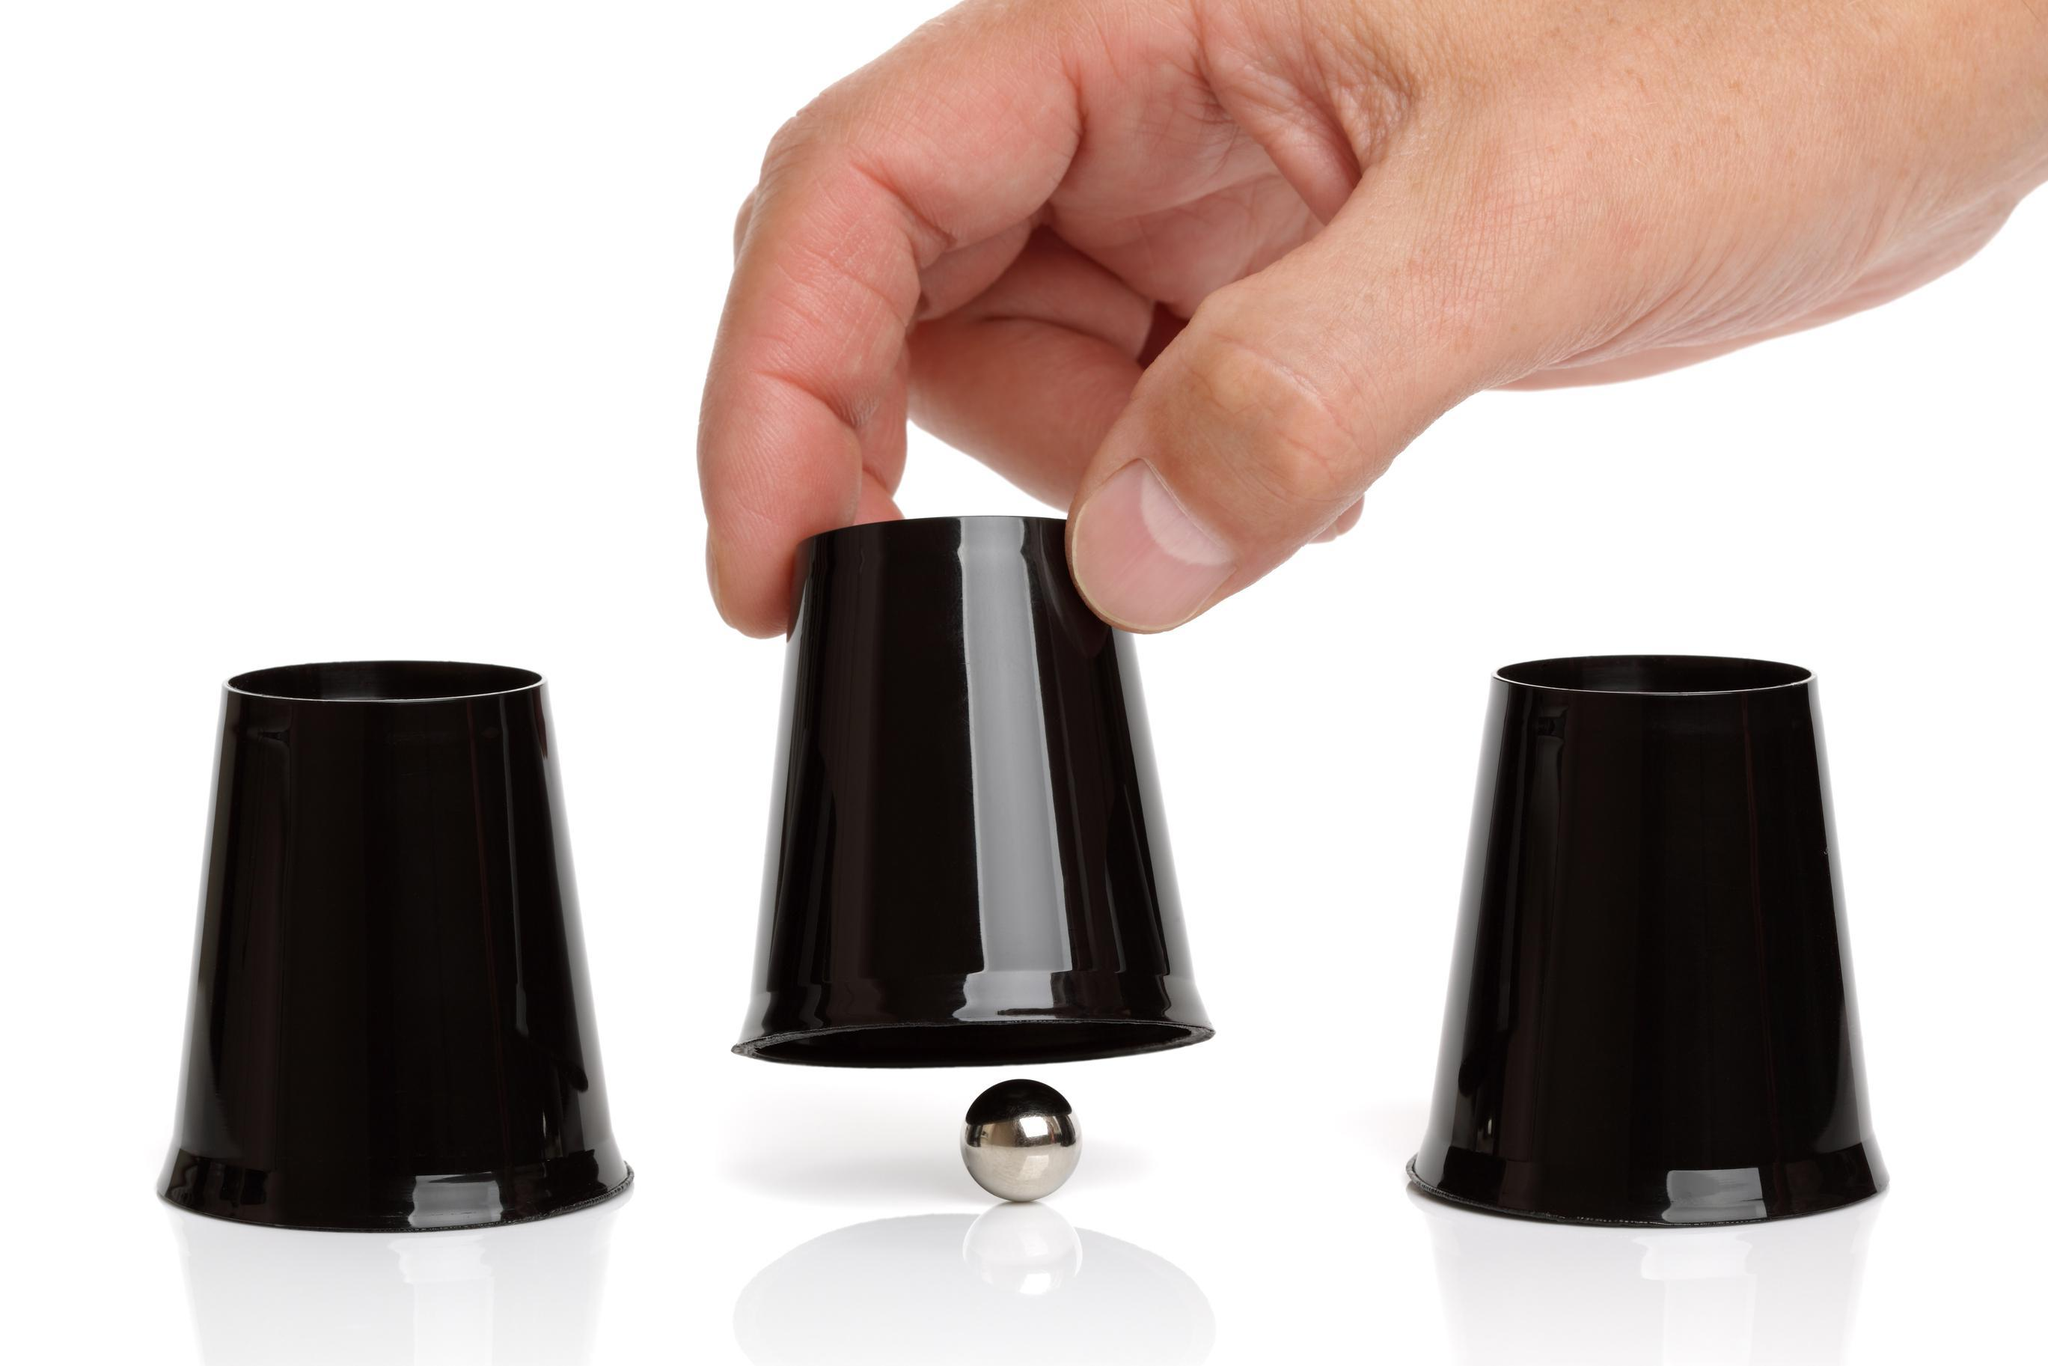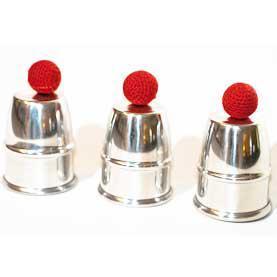The first image is the image on the left, the second image is the image on the right. For the images displayed, is the sentence "There is no more than one red ball." factually correct? Answer yes or no. No. 